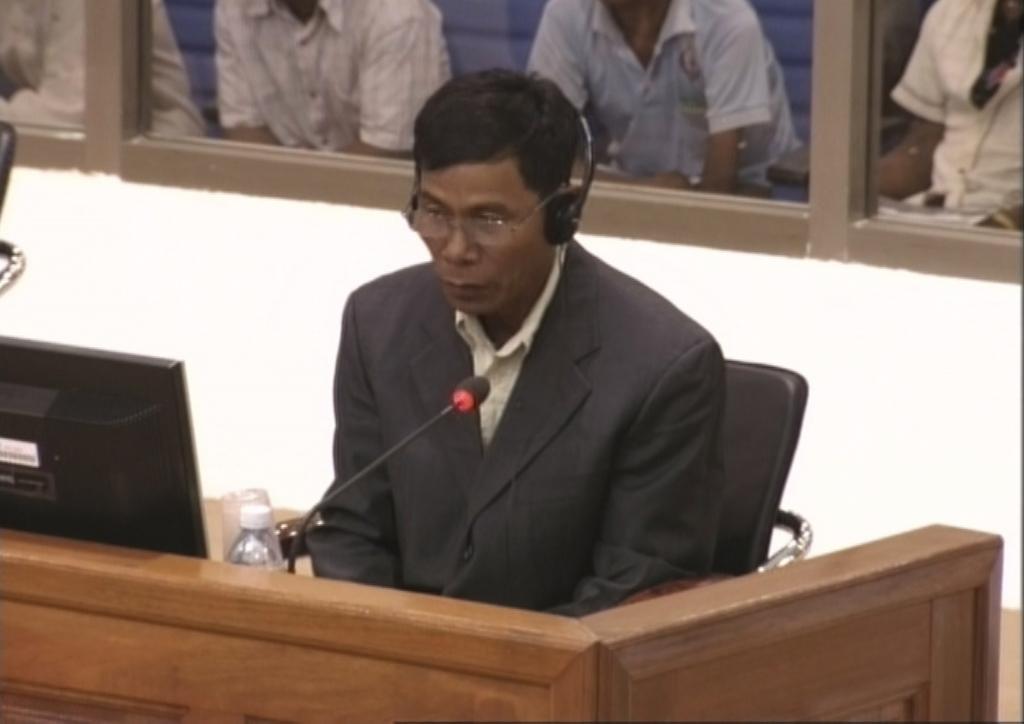Please provide a concise description of this image. In this image man sitting on the chair wearing a headphone in front of the mic. In the center there is a monitor, bottle on the desk of this man. In the background there are four person sitting and a wall. 